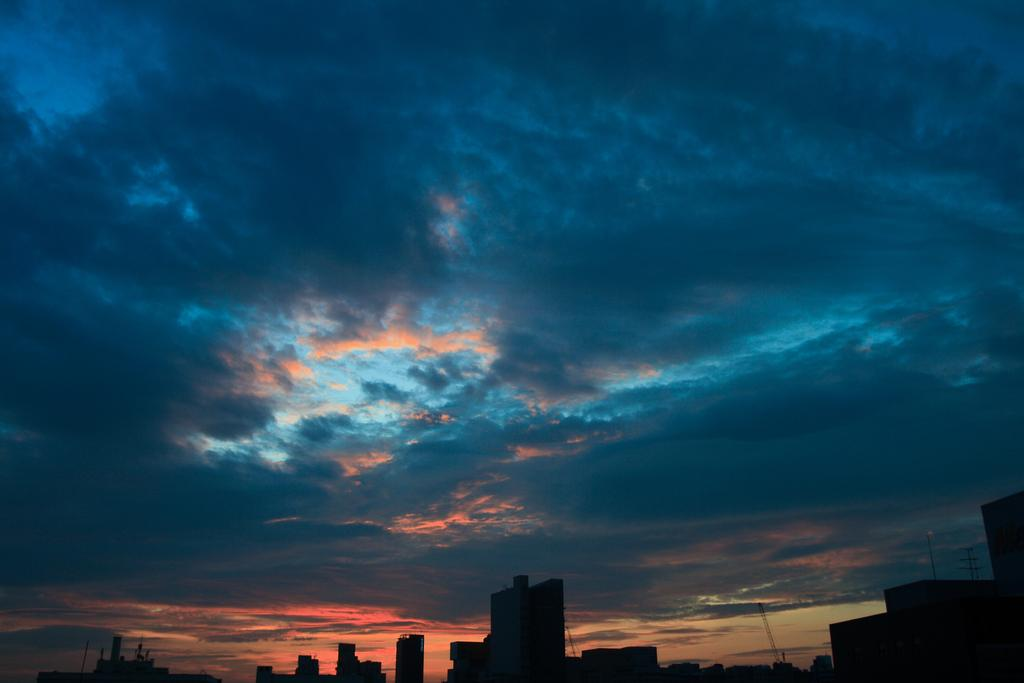What type of structures are present in the image? There are buildings in the image. What else can be seen besides the buildings? There are poles in the image. What is visible at the top of the image? The sky is visible at the top of the image. What can be observed in the sky? There are clouds in the sky. Can you tell me how many hydrants are present in the image? There are no hydrants visible in the image; it only features buildings, poles, and clouds in the sky. 